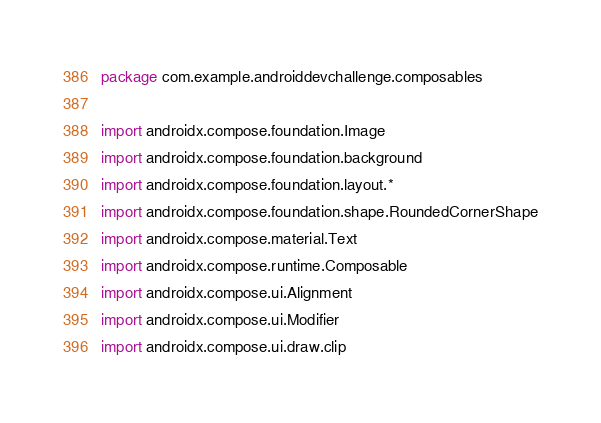Convert code to text. <code><loc_0><loc_0><loc_500><loc_500><_Kotlin_>package com.example.androiddevchallenge.composables

import androidx.compose.foundation.Image
import androidx.compose.foundation.background
import androidx.compose.foundation.layout.*
import androidx.compose.foundation.shape.RoundedCornerShape
import androidx.compose.material.Text
import androidx.compose.runtime.Composable
import androidx.compose.ui.Alignment
import androidx.compose.ui.Modifier
import androidx.compose.ui.draw.clip</code> 